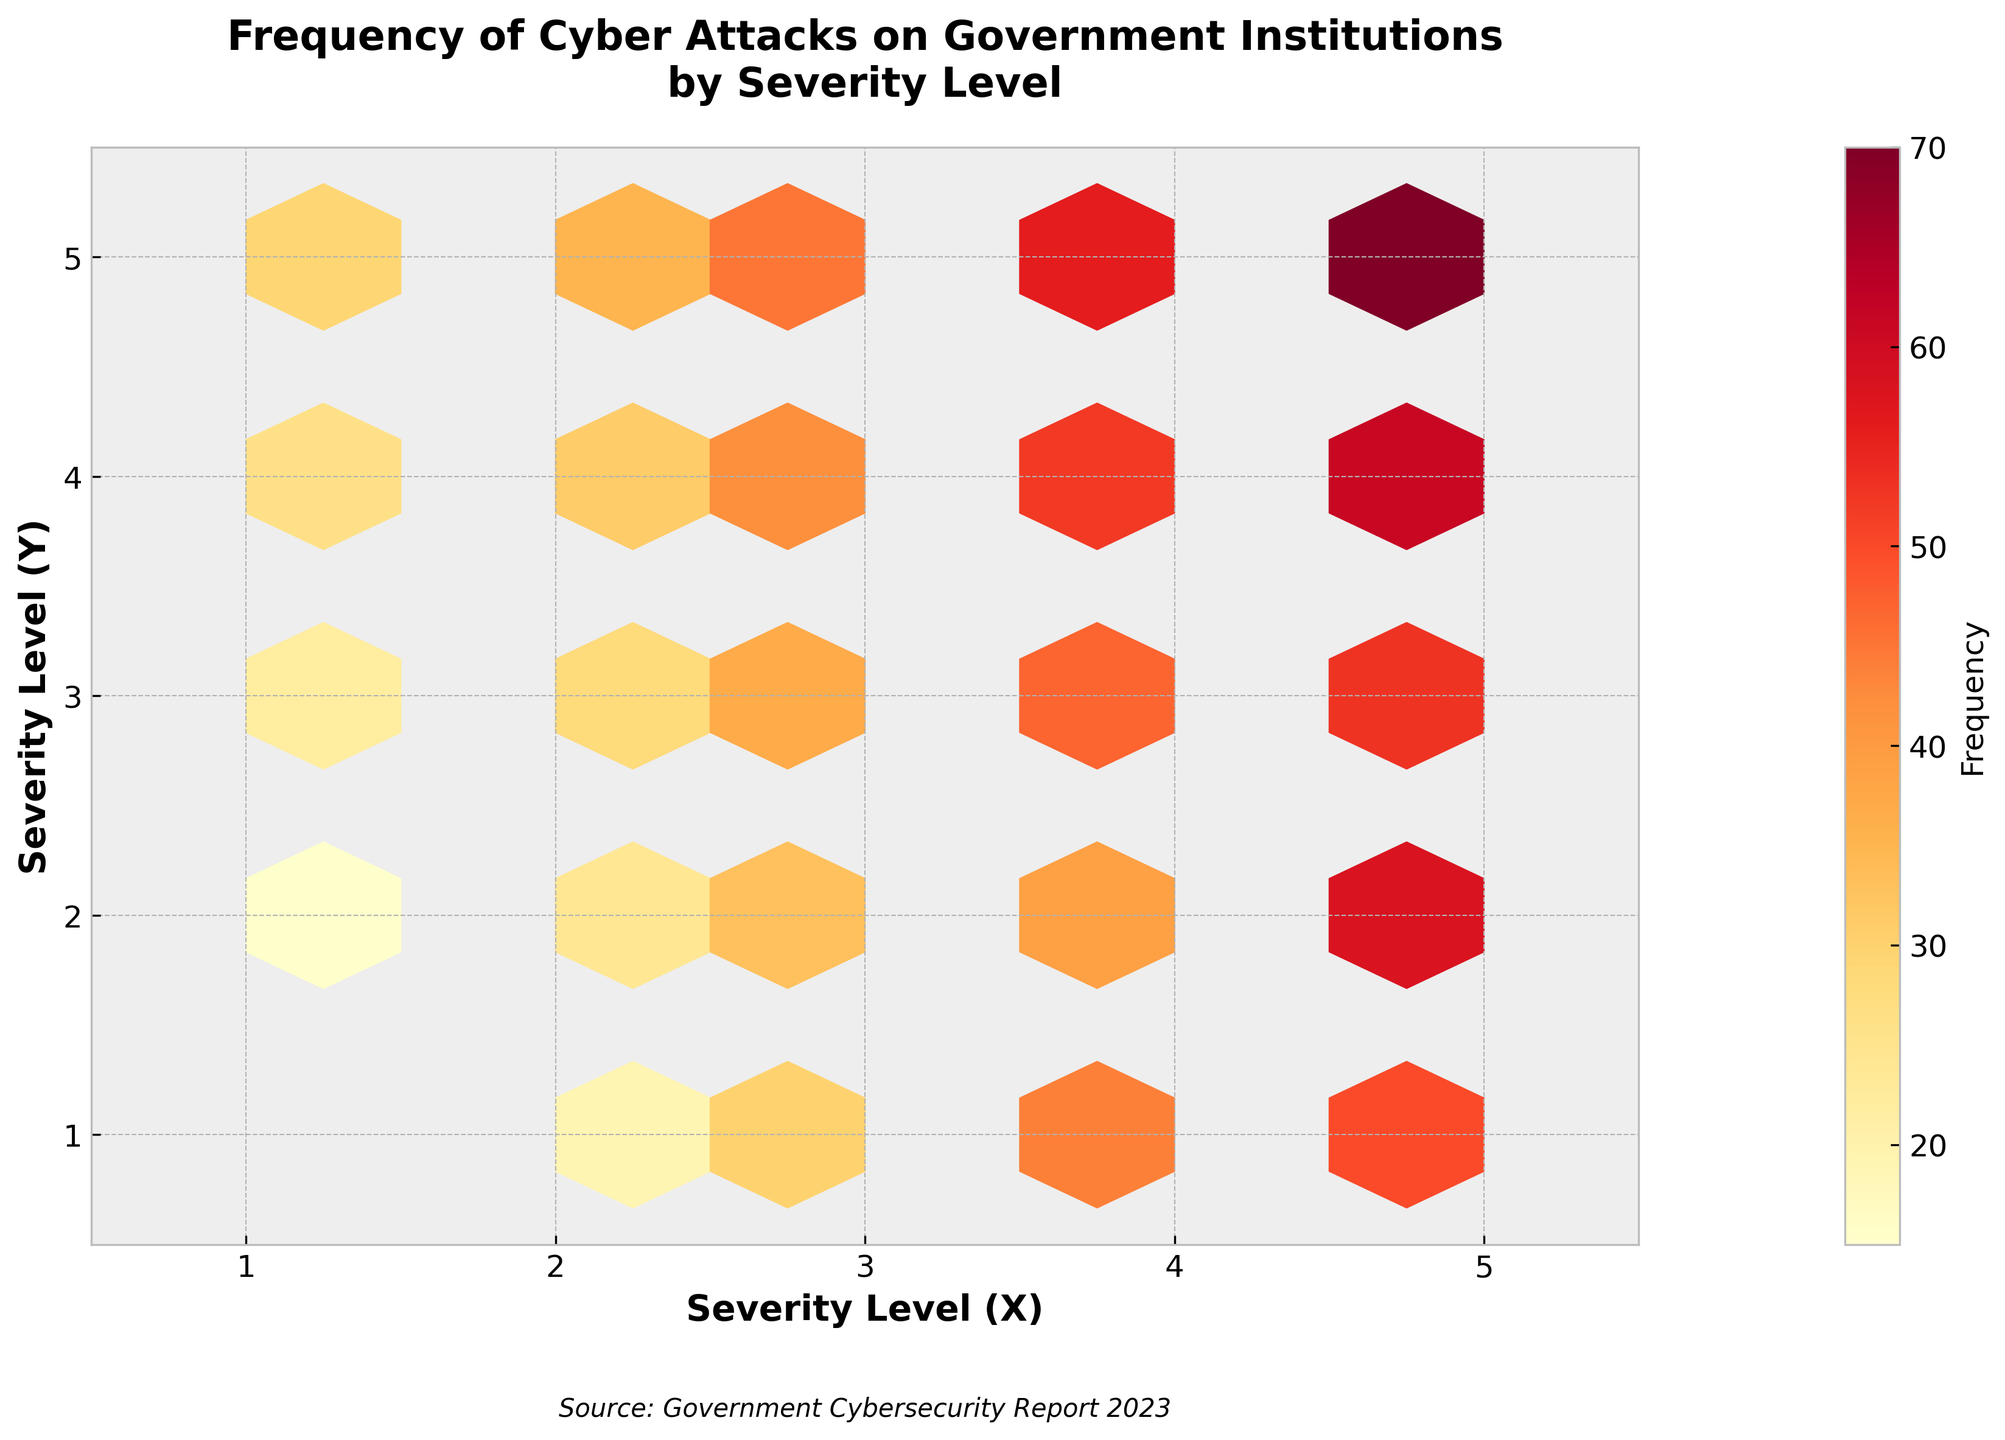What's the title of the figure? The title of the plot is written at the top of the figure in boldface. It is usually the most prominent text.
Answer: Frequency of Cyber Attacks on Government Institutions by Severity Level What do the X and Y axes represent? The labels on the X and Y axes indicate what they represent. They are labeled "Severity Level (X)" and "Severity Level (Y)" respectively.
Answer: Severity levels What does the color scale represent? The color scale on the right side of the plot is labeled with "Frequency" and the color bar shows a gradient from light to dark. This indicates that the color represents the frequency of cyber attacks.
Answer: Frequency At which severity level combination is the frequency of cyber attacks highest? The hexagon with the darkest color indicates the highest frequency. By observing the plot, the darkest hexagon is at the intersection of severity level 5 for both X and Y axes.
Answer: Severity level 5,5 How many severity level combinations have a frequency greater than 50? Hexagons that are darker or have colors indicating higher frequency can be counted. Observing the hexagons sequentially, there are three (5,1), (5,4), and (5,5) that show such high frequency.
Answer: 3 Which combination of severity levels has the lowest frequency of cyber attacks? The hexagon with the lightest color or nearly no fill indicates the lowest frequency. It occurs at the intersection of severity level 1 for X and 2 for Y.
Answer: Severity level 1,2 What is the primary source of data indicated in the figure? The source of the data is usually indicated at the bottom of the plot in italics. The text reads "Source: Government Cybersecurity Report 2023".
Answer: Government Cybersecurity Report 2023 Which severity level on the Y-axis has the most uniformly distributed frequencies across various levels on the X-axis? Examining each severity level on the Y-axis, and observing the distribution of colors along the X-axis, we find that level 3 on the Y-axis has a more even distribution compared to others.
Answer: Level 3 How does the frequency of cyber attacks at severity level 4,4 compare to that at severity level 1,5? By comparing the color intensities, we see that the hexagon at (4,4) has a darker shade compared to the hexagon at (1,5), indicating a higher frequency at (4,4).
Answer: Higher at severity level 4,4 What trend can be observed regarding the frequency of cyber attacks on higher severity levels? Observing the color intensities, it is noticeable that the frequencies generally increase with higher severity levels, becoming darker towards severity level 5.
Answer: Increases with higher severity levels 